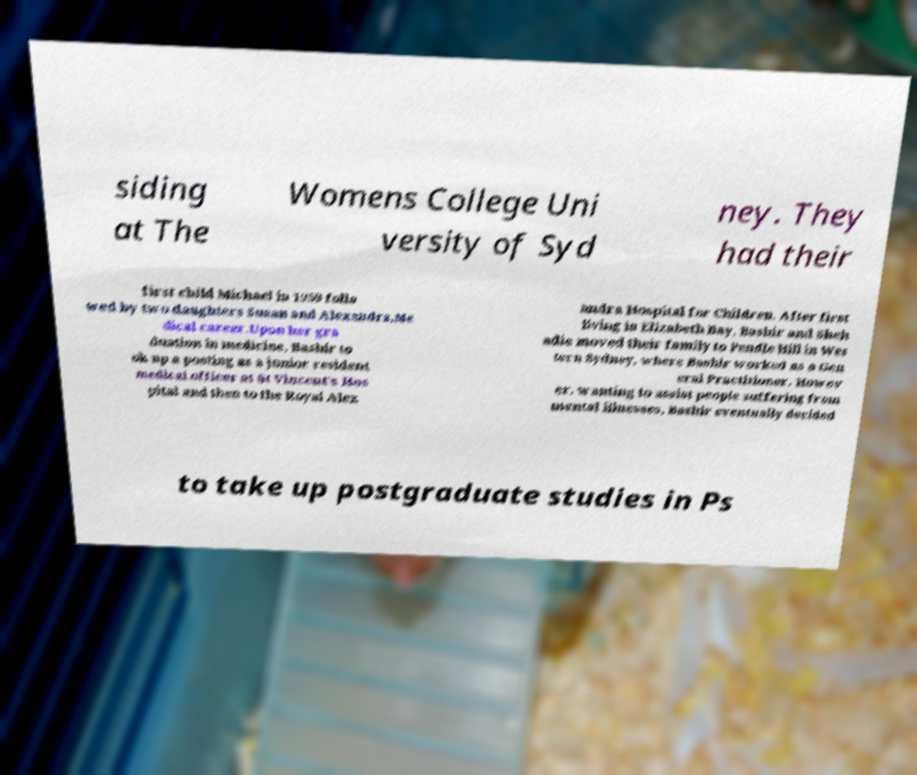Could you extract and type out the text from this image? siding at The Womens College Uni versity of Syd ney. They had their first child Michael in 1959 follo wed by two daughters Susan and Alexandra.Me dical career.Upon her gra duation in medicine, Bashir to ok up a posting as a junior resident medical officer at St Vincent's Hos pital and then to the Royal Alex andra Hospital for Children. After first living in Elizabeth Bay, Bashir and Sheh adie moved their family to Pendle Hill in Wes tern Sydney, where Bashir worked as a Gen eral Practitioner. Howev er, wanting to assist people suffering from mental illnesses, Bashir eventually decided to take up postgraduate studies in Ps 